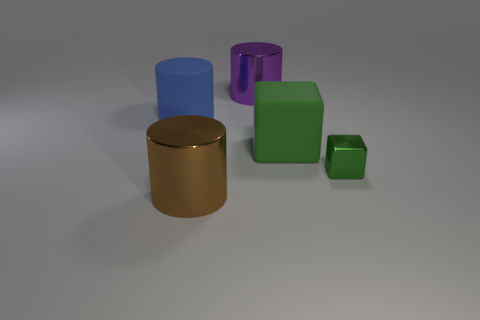Add 1 rubber cylinders. How many objects exist? 6 Subtract all cubes. How many objects are left? 3 Add 3 large metal objects. How many large metal objects are left? 5 Add 1 green things. How many green things exist? 3 Subtract 0 brown balls. How many objects are left? 5 Subtract all big brown metal objects. Subtract all large blue matte objects. How many objects are left? 3 